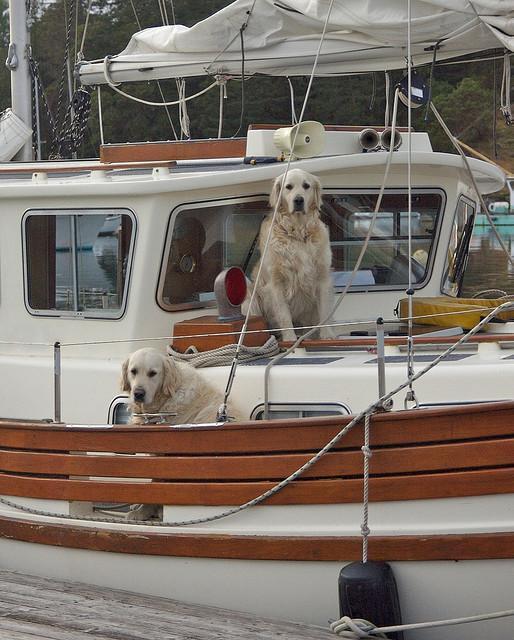How many dogs are riding on the boat?
Give a very brief answer. 2. How many dogs are in the photo?
Give a very brief answer. 2. 